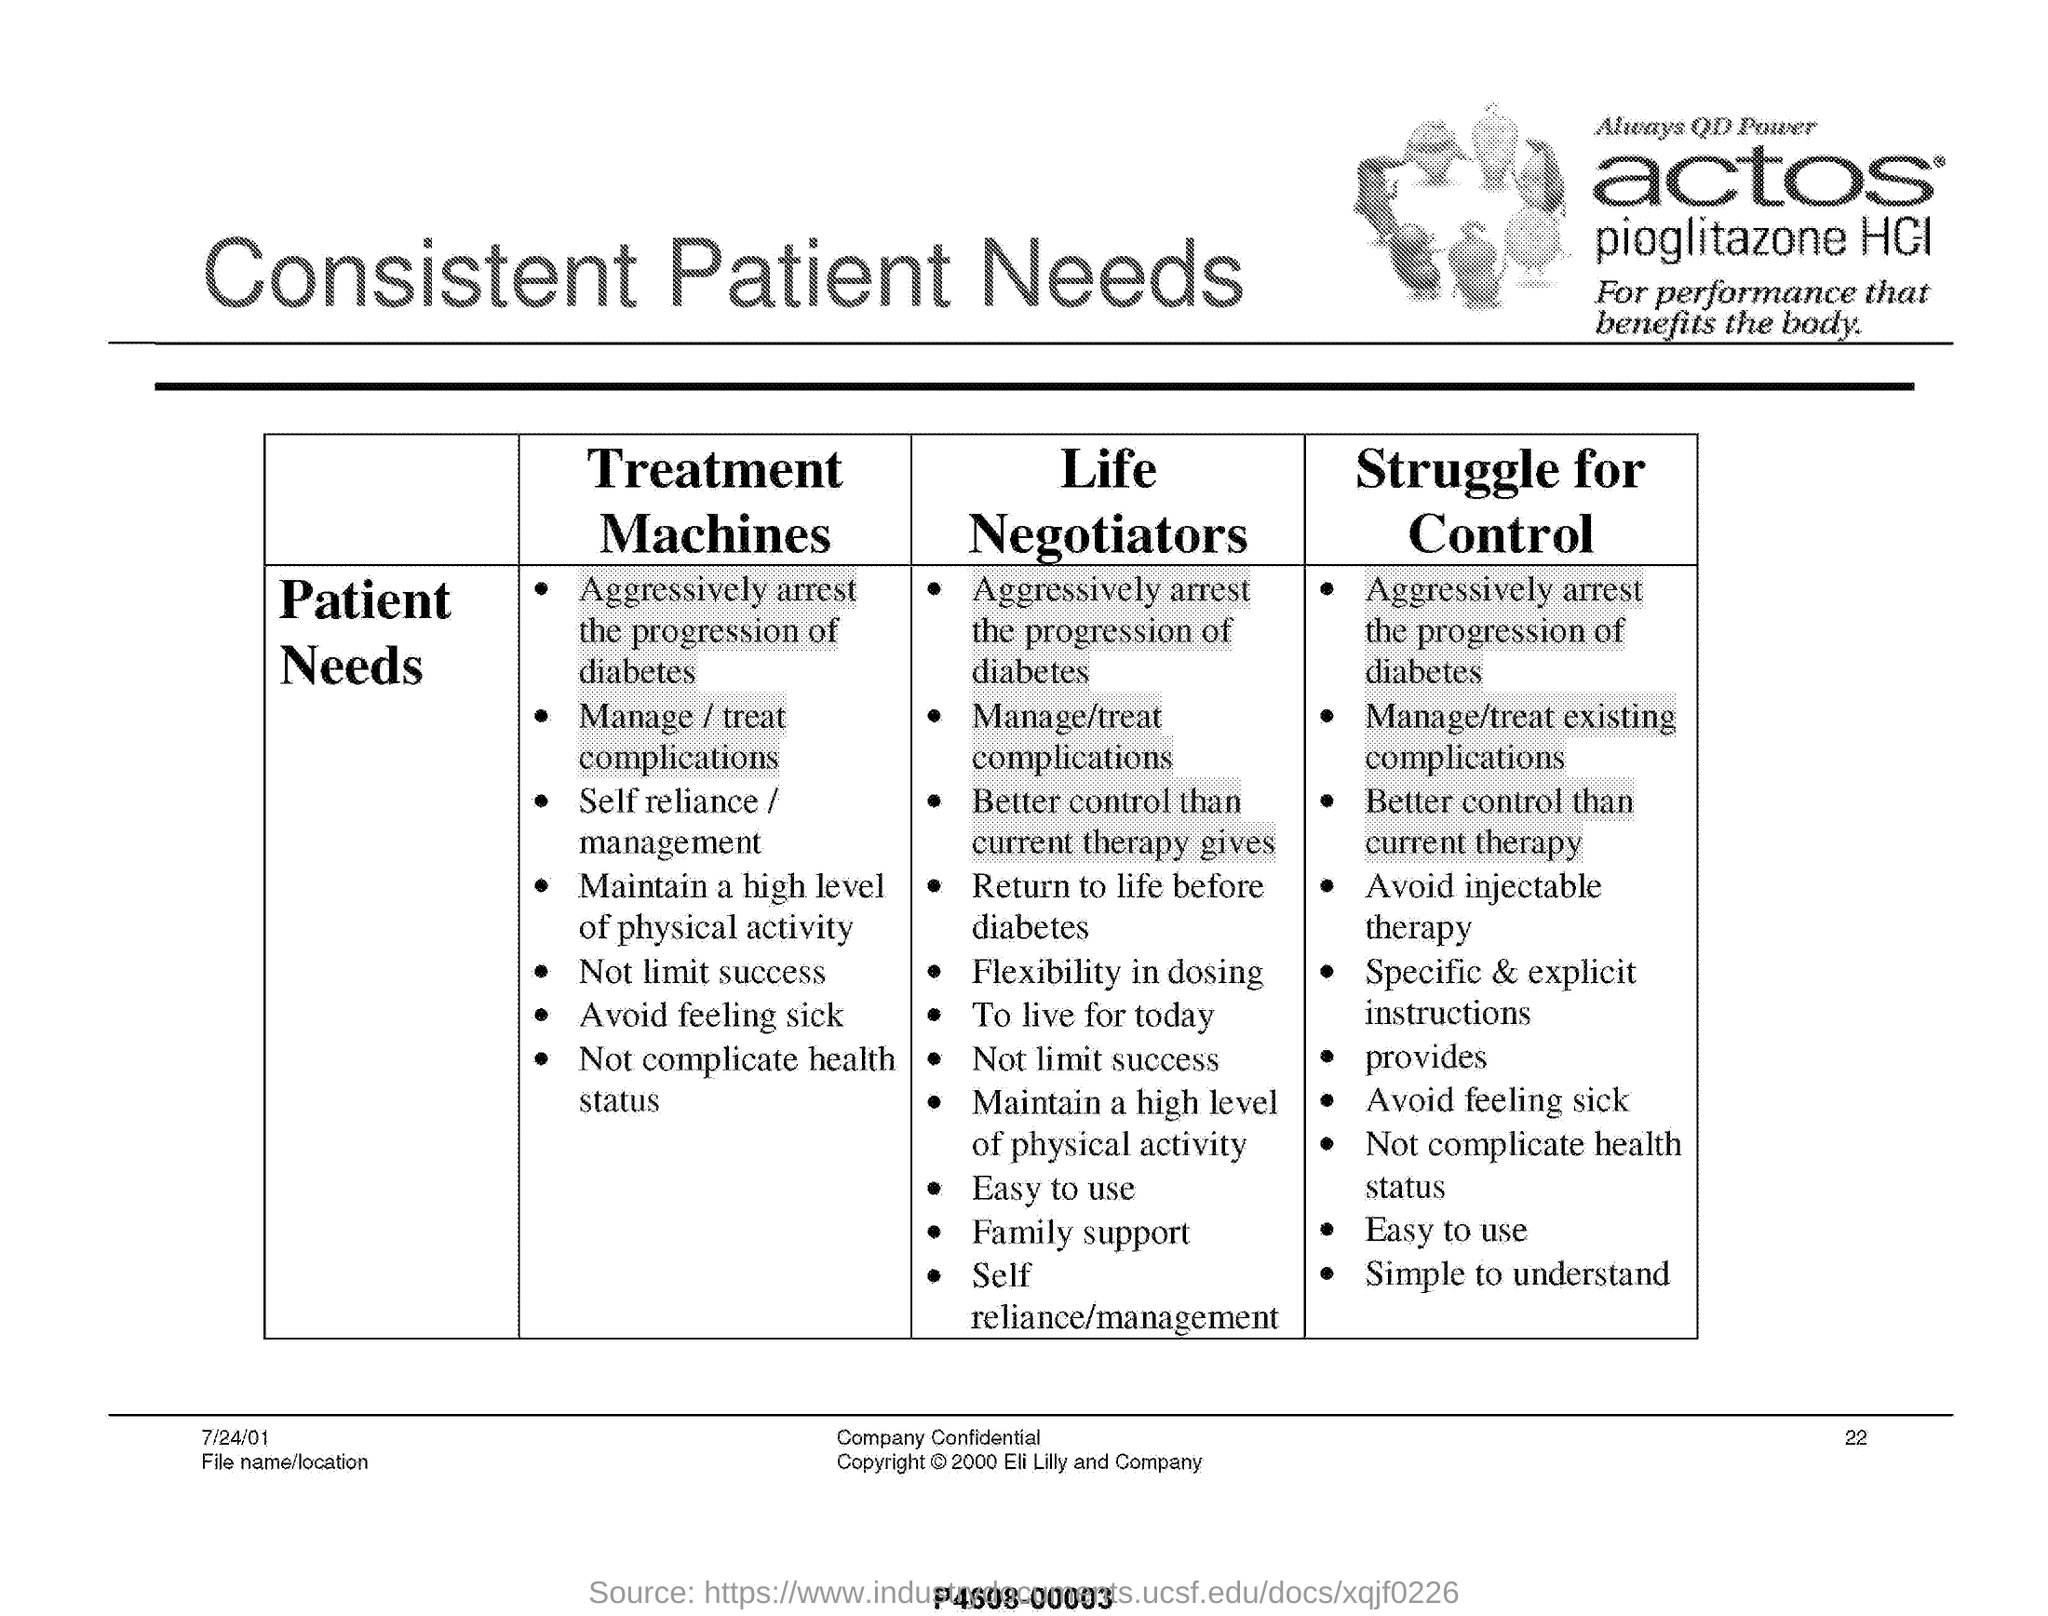What is the date mentioned in this document?
Make the answer very short. 7/24/01. What is the page no mentioned in this document?
Ensure brevity in your answer.  22. 